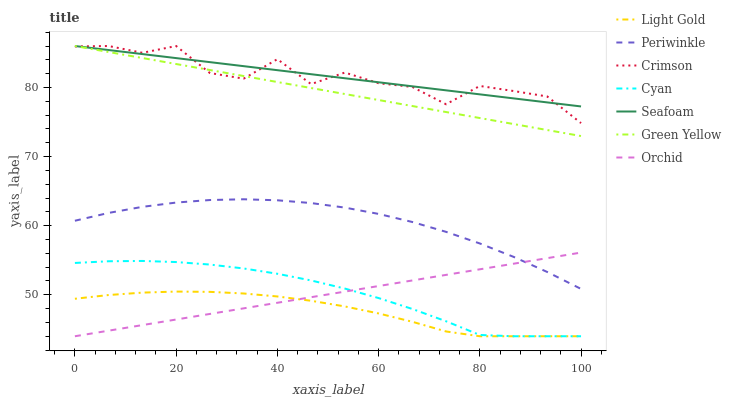Does Light Gold have the minimum area under the curve?
Answer yes or no. Yes. Does Seafoam have the maximum area under the curve?
Answer yes or no. Yes. Does Periwinkle have the minimum area under the curve?
Answer yes or no. No. Does Periwinkle have the maximum area under the curve?
Answer yes or no. No. Is Orchid the smoothest?
Answer yes or no. Yes. Is Crimson the roughest?
Answer yes or no. Yes. Is Periwinkle the smoothest?
Answer yes or no. No. Is Periwinkle the roughest?
Answer yes or no. No. Does Cyan have the lowest value?
Answer yes or no. Yes. Does Periwinkle have the lowest value?
Answer yes or no. No. Does Green Yellow have the highest value?
Answer yes or no. Yes. Does Periwinkle have the highest value?
Answer yes or no. No. Is Light Gold less than Crimson?
Answer yes or no. Yes. Is Crimson greater than Cyan?
Answer yes or no. Yes. Does Green Yellow intersect Seafoam?
Answer yes or no. Yes. Is Green Yellow less than Seafoam?
Answer yes or no. No. Is Green Yellow greater than Seafoam?
Answer yes or no. No. Does Light Gold intersect Crimson?
Answer yes or no. No. 